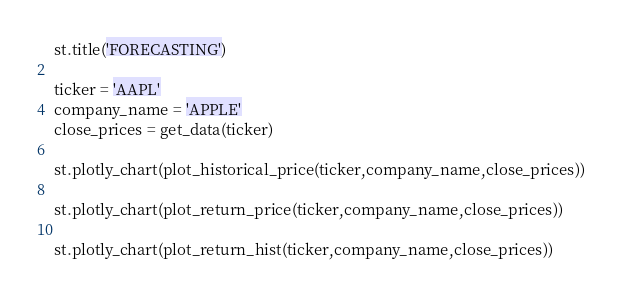<code> <loc_0><loc_0><loc_500><loc_500><_Python_>st.title('FORECASTING')

ticker = 'AAPL'
company_name = 'APPLE'
close_prices = get_data(ticker)

st.plotly_chart(plot_historical_price(ticker,company_name,close_prices))

st.plotly_chart(plot_return_price(ticker,company_name,close_prices))

st.plotly_chart(plot_return_hist(ticker,company_name,close_prices))</code> 